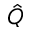Convert formula to latex. <formula><loc_0><loc_0><loc_500><loc_500>\hat { Q }</formula> 